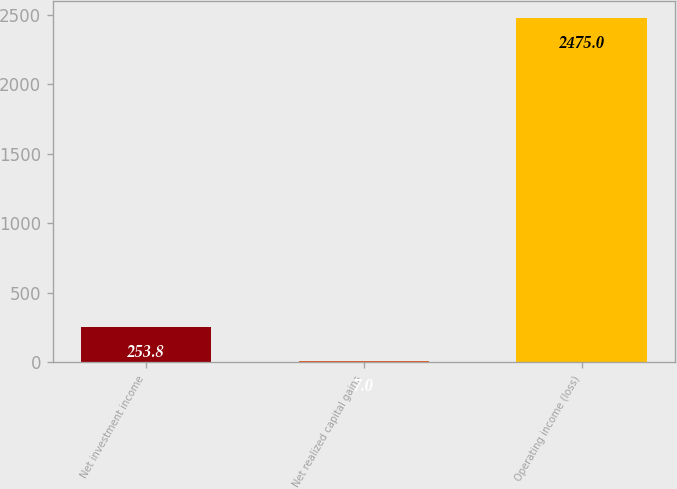Convert chart to OTSL. <chart><loc_0><loc_0><loc_500><loc_500><bar_chart><fcel>Net investment income<fcel>Net realized capital gains<fcel>Operating income (loss)<nl><fcel>253.8<fcel>7<fcel>2475<nl></chart> 